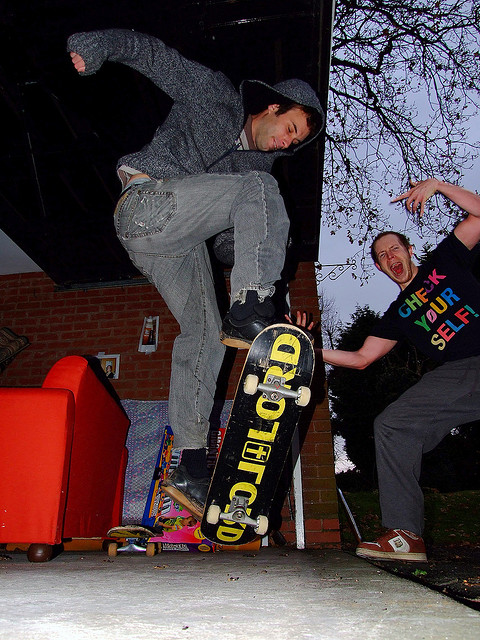Please transcribe the text information in this image. SELF! your CHECK 